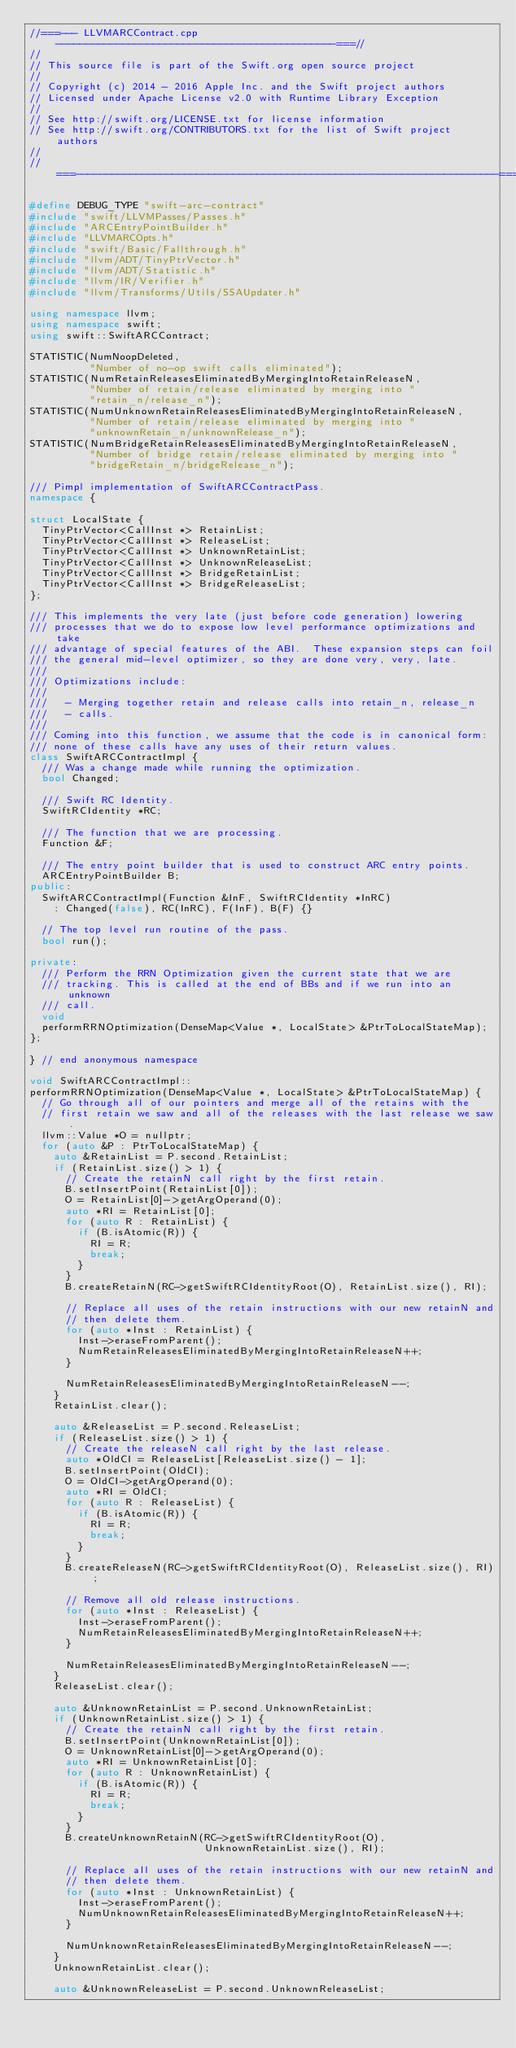Convert code to text. <code><loc_0><loc_0><loc_500><loc_500><_C++_>//===--- LLVMARCContract.cpp ----------------------------------------------===//
//
// This source file is part of the Swift.org open source project
//
// Copyright (c) 2014 - 2016 Apple Inc. and the Swift project authors
// Licensed under Apache License v2.0 with Runtime Library Exception
//
// See http://swift.org/LICENSE.txt for license information
// See http://swift.org/CONTRIBUTORS.txt for the list of Swift project authors
//
//===----------------------------------------------------------------------===//

#define DEBUG_TYPE "swift-arc-contract"
#include "swift/LLVMPasses/Passes.h"
#include "ARCEntryPointBuilder.h"
#include "LLVMARCOpts.h"
#include "swift/Basic/Fallthrough.h"
#include "llvm/ADT/TinyPtrVector.h"
#include "llvm/ADT/Statistic.h"
#include "llvm/IR/Verifier.h"
#include "llvm/Transforms/Utils/SSAUpdater.h"

using namespace llvm;
using namespace swift;
using swift::SwiftARCContract;

STATISTIC(NumNoopDeleted,
          "Number of no-op swift calls eliminated");
STATISTIC(NumRetainReleasesEliminatedByMergingIntoRetainReleaseN,
          "Number of retain/release eliminated by merging into "
          "retain_n/release_n");
STATISTIC(NumUnknownRetainReleasesEliminatedByMergingIntoRetainReleaseN,
          "Number of retain/release eliminated by merging into "
          "unknownRetain_n/unknownRelease_n");
STATISTIC(NumBridgeRetainReleasesEliminatedByMergingIntoRetainReleaseN,
          "Number of bridge retain/release eliminated by merging into "
          "bridgeRetain_n/bridgeRelease_n");

/// Pimpl implementation of SwiftARCContractPass.
namespace {

struct LocalState {
  TinyPtrVector<CallInst *> RetainList;
  TinyPtrVector<CallInst *> ReleaseList;
  TinyPtrVector<CallInst *> UnknownRetainList;
  TinyPtrVector<CallInst *> UnknownReleaseList;
  TinyPtrVector<CallInst *> BridgeRetainList;
  TinyPtrVector<CallInst *> BridgeReleaseList;
};

/// This implements the very late (just before code generation) lowering
/// processes that we do to expose low level performance optimizations and take
/// advantage of special features of the ABI.  These expansion steps can foil
/// the general mid-level optimizer, so they are done very, very, late.
///
/// Optimizations include:
///
///   - Merging together retain and release calls into retain_n, release_n
///   - calls.
///
/// Coming into this function, we assume that the code is in canonical form:
/// none of these calls have any uses of their return values.
class SwiftARCContractImpl {
  /// Was a change made while running the optimization.
  bool Changed;

  /// Swift RC Identity.
  SwiftRCIdentity *RC;

  /// The function that we are processing.
  Function &F;

  /// The entry point builder that is used to construct ARC entry points.
  ARCEntryPointBuilder B;
public:
  SwiftARCContractImpl(Function &InF, SwiftRCIdentity *InRC)
    : Changed(false), RC(InRC), F(InF), B(F) {}

  // The top level run routine of the pass.
  bool run();

private:
  /// Perform the RRN Optimization given the current state that we are
  /// tracking. This is called at the end of BBs and if we run into an unknown
  /// call.
  void
  performRRNOptimization(DenseMap<Value *, LocalState> &PtrToLocalStateMap);
};

} // end anonymous namespace

void SwiftARCContractImpl::
performRRNOptimization(DenseMap<Value *, LocalState> &PtrToLocalStateMap) {
  // Go through all of our pointers and merge all of the retains with the
  // first retain we saw and all of the releases with the last release we saw.
  llvm::Value *O = nullptr;
  for (auto &P : PtrToLocalStateMap) {
    auto &RetainList = P.second.RetainList;
    if (RetainList.size() > 1) {
      // Create the retainN call right by the first retain.
      B.setInsertPoint(RetainList[0]);
      O = RetainList[0]->getArgOperand(0);
      auto *RI = RetainList[0];
      for (auto R : RetainList) {
        if (B.isAtomic(R)) {
          RI = R;
          break;
        }
      }
      B.createRetainN(RC->getSwiftRCIdentityRoot(O), RetainList.size(), RI);

      // Replace all uses of the retain instructions with our new retainN and
      // then delete them.
      for (auto *Inst : RetainList) {
        Inst->eraseFromParent();
        NumRetainReleasesEliminatedByMergingIntoRetainReleaseN++;
      }

      NumRetainReleasesEliminatedByMergingIntoRetainReleaseN--;
    }
    RetainList.clear();

    auto &ReleaseList = P.second.ReleaseList;
    if (ReleaseList.size() > 1) {
      // Create the releaseN call right by the last release.
      auto *OldCI = ReleaseList[ReleaseList.size() - 1];
      B.setInsertPoint(OldCI);
      O = OldCI->getArgOperand(0);
      auto *RI = OldCI;
      for (auto R : ReleaseList) {
        if (B.isAtomic(R)) {
          RI = R;
          break;
        }
      }
      B.createReleaseN(RC->getSwiftRCIdentityRoot(O), ReleaseList.size(), RI);

      // Remove all old release instructions.
      for (auto *Inst : ReleaseList) {
        Inst->eraseFromParent();
        NumRetainReleasesEliminatedByMergingIntoRetainReleaseN++;
      }

      NumRetainReleasesEliminatedByMergingIntoRetainReleaseN--;
    }
    ReleaseList.clear();

    auto &UnknownRetainList = P.second.UnknownRetainList;
    if (UnknownRetainList.size() > 1) {
      // Create the retainN call right by the first retain.
      B.setInsertPoint(UnknownRetainList[0]);
      O = UnknownRetainList[0]->getArgOperand(0);
      auto *RI = UnknownRetainList[0];
      for (auto R : UnknownRetainList) {
        if (B.isAtomic(R)) {
          RI = R;
          break;
        }
      }
      B.createUnknownRetainN(RC->getSwiftRCIdentityRoot(O),
                             UnknownRetainList.size(), RI);

      // Replace all uses of the retain instructions with our new retainN and
      // then delete them.
      for (auto *Inst : UnknownRetainList) {
        Inst->eraseFromParent();
        NumUnknownRetainReleasesEliminatedByMergingIntoRetainReleaseN++;
      }

      NumUnknownRetainReleasesEliminatedByMergingIntoRetainReleaseN--;
    }
    UnknownRetainList.clear();

    auto &UnknownReleaseList = P.second.UnknownReleaseList;</code> 